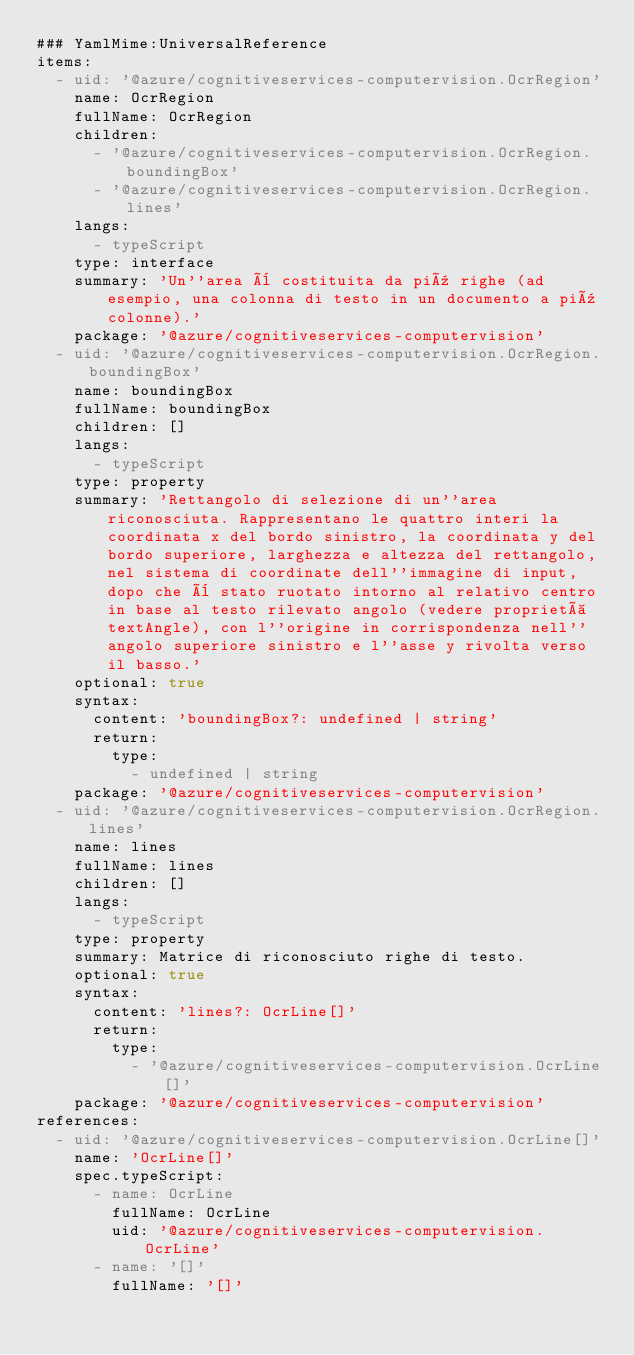<code> <loc_0><loc_0><loc_500><loc_500><_YAML_>### YamlMime:UniversalReference
items:
  - uid: '@azure/cognitiveservices-computervision.OcrRegion'
    name: OcrRegion
    fullName: OcrRegion
    children:
      - '@azure/cognitiveservices-computervision.OcrRegion.boundingBox'
      - '@azure/cognitiveservices-computervision.OcrRegion.lines'
    langs:
      - typeScript
    type: interface
    summary: 'Un''area è costituita da più righe (ad esempio, una colonna di testo in un documento a più colonne).'
    package: '@azure/cognitiveservices-computervision'
  - uid: '@azure/cognitiveservices-computervision.OcrRegion.boundingBox'
    name: boundingBox
    fullName: boundingBox
    children: []
    langs:
      - typeScript
    type: property
    summary: 'Rettangolo di selezione di un''area riconosciuta. Rappresentano le quattro interi la coordinata x del bordo sinistro, la coordinata y del bordo superiore, larghezza e altezza del rettangolo, nel sistema di coordinate dell''immagine di input, dopo che è stato ruotato intorno al relativo centro in base al testo rilevato angolo (vedere proprietà textAngle), con l''origine in corrispondenza nell''angolo superiore sinistro e l''asse y rivolta verso il basso.'
    optional: true
    syntax:
      content: 'boundingBox?: undefined | string'
      return:
        type:
          - undefined | string
    package: '@azure/cognitiveservices-computervision'
  - uid: '@azure/cognitiveservices-computervision.OcrRegion.lines'
    name: lines
    fullName: lines
    children: []
    langs:
      - typeScript
    type: property
    summary: Matrice di riconosciuto righe di testo.
    optional: true
    syntax:
      content: 'lines?: OcrLine[]'
      return:
        type:
          - '@azure/cognitiveservices-computervision.OcrLine[]'
    package: '@azure/cognitiveservices-computervision'
references:
  - uid: '@azure/cognitiveservices-computervision.OcrLine[]'
    name: 'OcrLine[]'
    spec.typeScript:
      - name: OcrLine
        fullName: OcrLine
        uid: '@azure/cognitiveservices-computervision.OcrLine'
      - name: '[]'
        fullName: '[]'</code> 